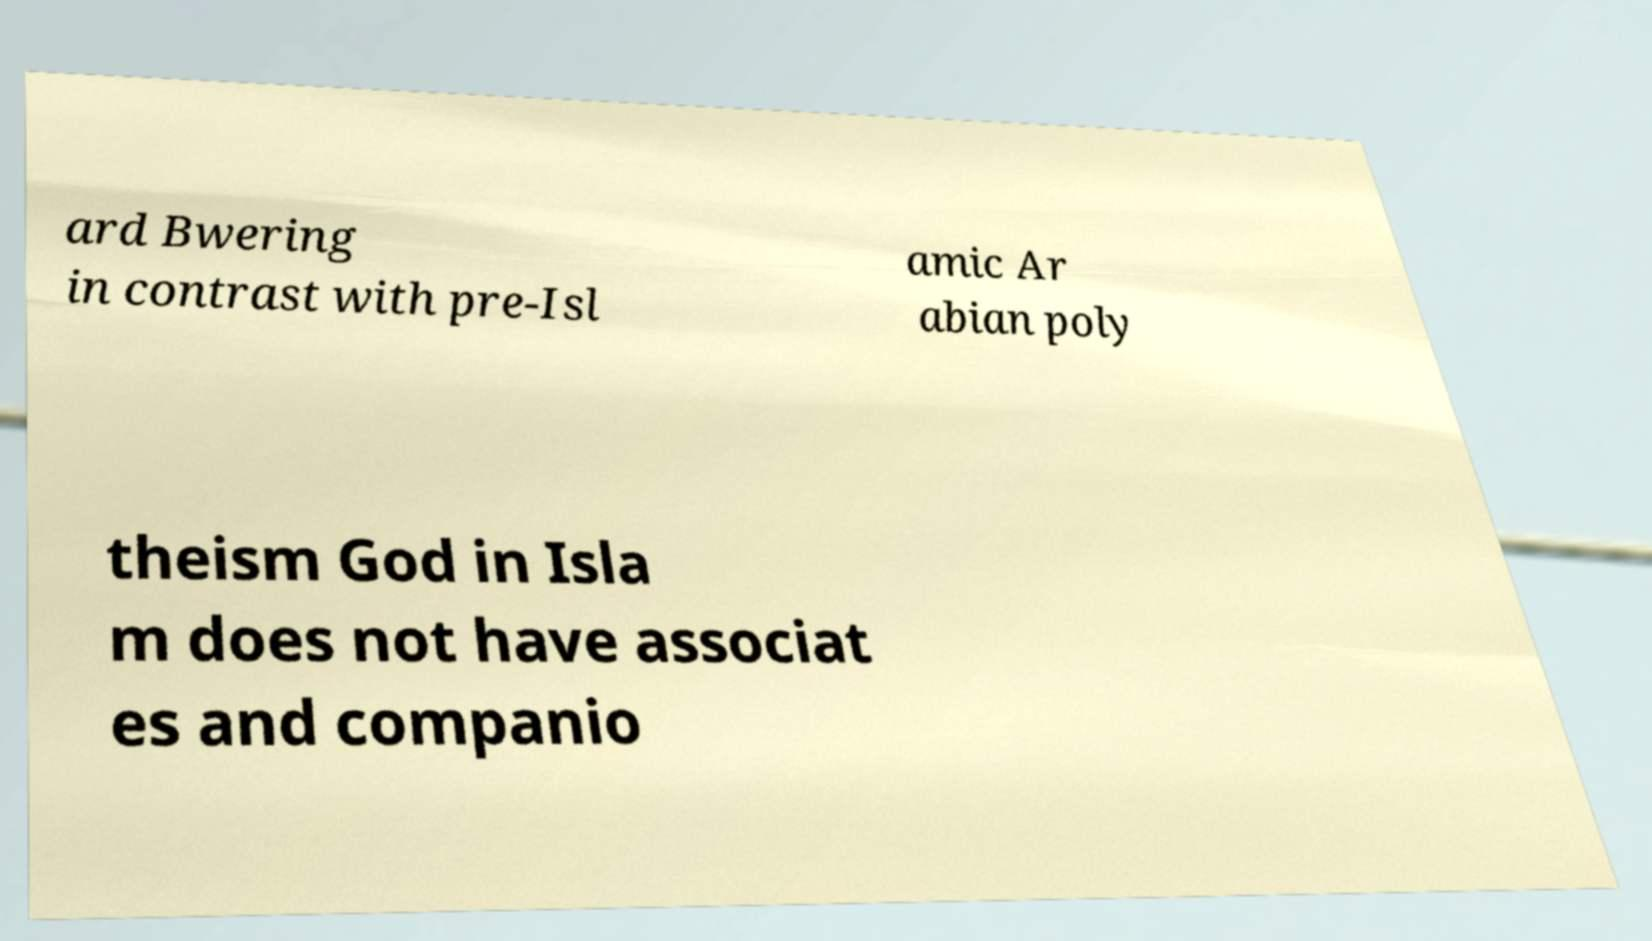I need the written content from this picture converted into text. Can you do that? ard Bwering in contrast with pre-Isl amic Ar abian poly theism God in Isla m does not have associat es and companio 